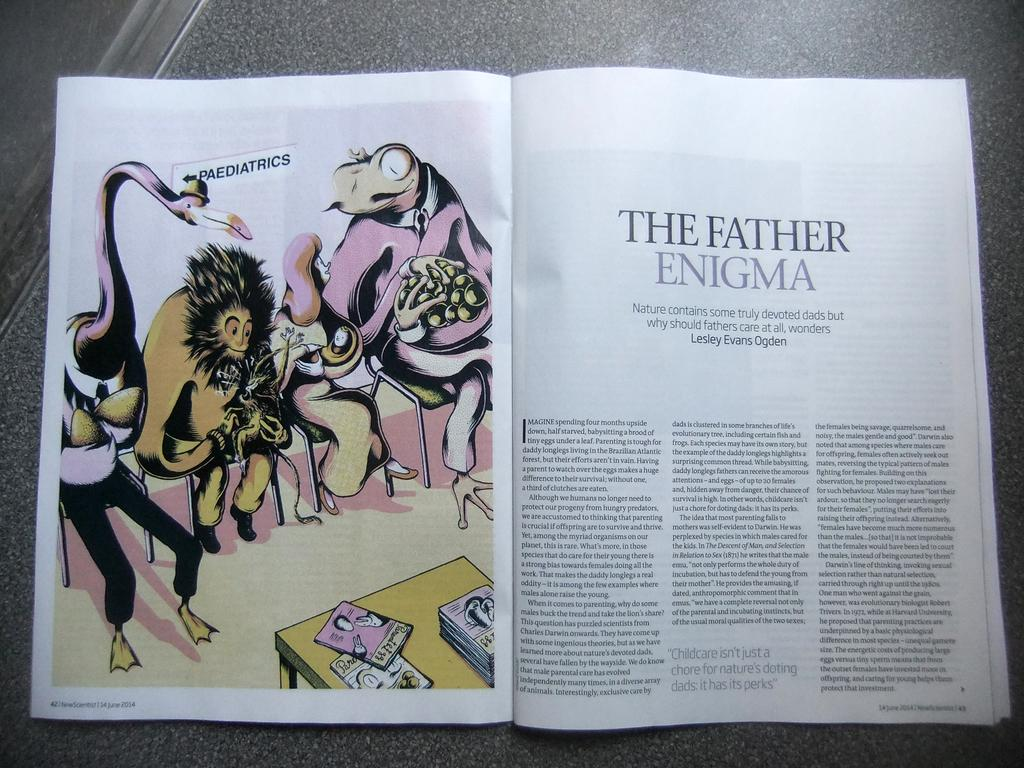<image>
Offer a succinct explanation of the picture presented. A magazine with an article called The Father Enigma. 